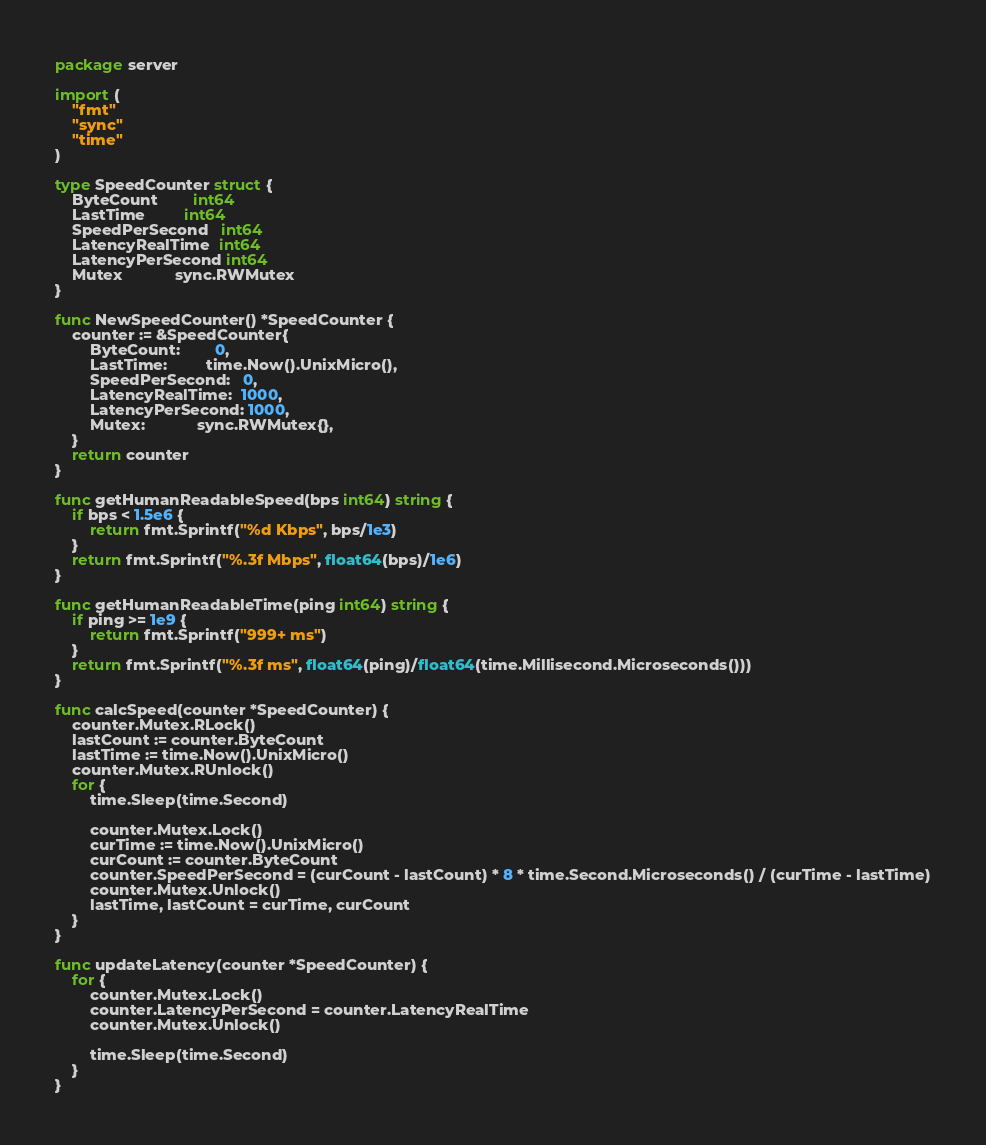Convert code to text. <code><loc_0><loc_0><loc_500><loc_500><_Go_>package server

import (
	"fmt"
	"sync"
	"time"
)

type SpeedCounter struct {
	ByteCount        int64
	LastTime         int64
	SpeedPerSecond   int64
	LatencyRealTime  int64
	LatencyPerSecond int64
	Mutex            sync.RWMutex
}

func NewSpeedCounter() *SpeedCounter {
	counter := &SpeedCounter{
		ByteCount:        0,
		LastTime:         time.Now().UnixMicro(),
		SpeedPerSecond:   0,
		LatencyRealTime:  1000,
		LatencyPerSecond: 1000,
		Mutex:            sync.RWMutex{},
	}
	return counter
}

func getHumanReadableSpeed(bps int64) string {
	if bps < 1.5e6 {
		return fmt.Sprintf("%d Kbps", bps/1e3)
	}
	return fmt.Sprintf("%.3f Mbps", float64(bps)/1e6)
}

func getHumanReadableTime(ping int64) string {
	if ping >= 1e9 {
		return fmt.Sprintf("999+ ms")
	}
	return fmt.Sprintf("%.3f ms", float64(ping)/float64(time.Millisecond.Microseconds()))
}

func calcSpeed(counter *SpeedCounter) {
	counter.Mutex.RLock()
	lastCount := counter.ByteCount
	lastTime := time.Now().UnixMicro()
	counter.Mutex.RUnlock()
	for {
		time.Sleep(time.Second)

		counter.Mutex.Lock()
		curTime := time.Now().UnixMicro()
		curCount := counter.ByteCount
		counter.SpeedPerSecond = (curCount - lastCount) * 8 * time.Second.Microseconds() / (curTime - lastTime)
		counter.Mutex.Unlock()
		lastTime, lastCount = curTime, curCount
	}
}

func updateLatency(counter *SpeedCounter) {
	for {
		counter.Mutex.Lock()
		counter.LatencyPerSecond = counter.LatencyRealTime
		counter.Mutex.Unlock()

		time.Sleep(time.Second)
	}
}
</code> 